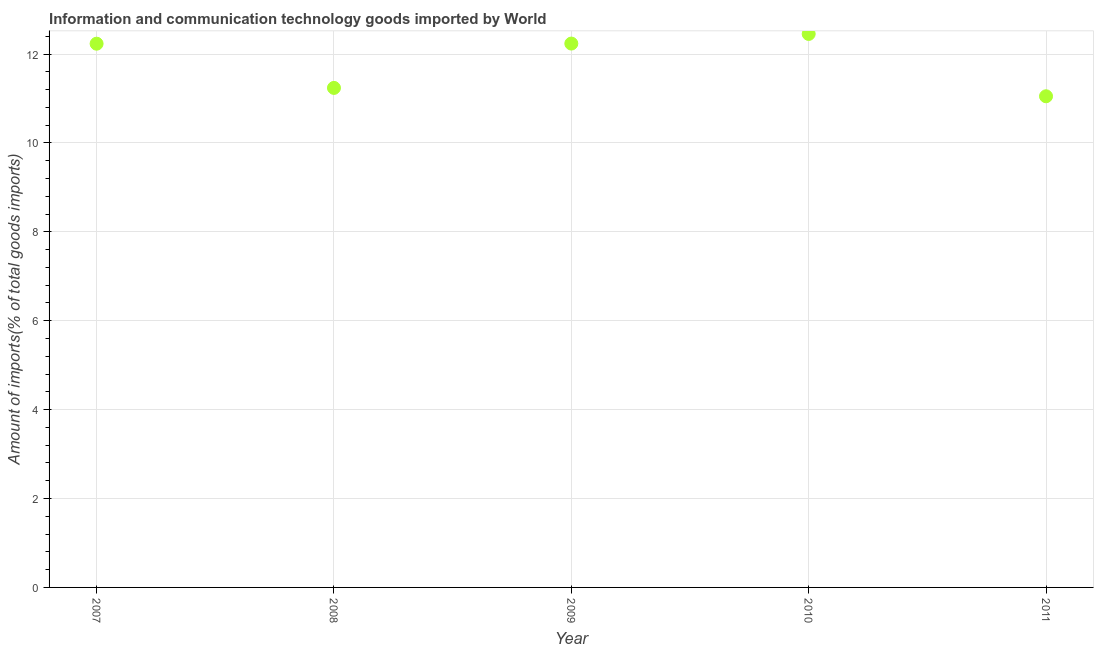What is the amount of ict goods imports in 2010?
Offer a very short reply. 12.45. Across all years, what is the maximum amount of ict goods imports?
Make the answer very short. 12.45. Across all years, what is the minimum amount of ict goods imports?
Ensure brevity in your answer.  11.05. In which year was the amount of ict goods imports maximum?
Your answer should be very brief. 2010. In which year was the amount of ict goods imports minimum?
Offer a terse response. 2011. What is the sum of the amount of ict goods imports?
Offer a terse response. 59.21. What is the difference between the amount of ict goods imports in 2008 and 2010?
Your response must be concise. -1.21. What is the average amount of ict goods imports per year?
Offer a terse response. 11.84. What is the median amount of ict goods imports?
Your response must be concise. 12.23. In how many years, is the amount of ict goods imports greater than 4.8 %?
Your answer should be compact. 5. Do a majority of the years between 2007 and 2008 (inclusive) have amount of ict goods imports greater than 5.2 %?
Your answer should be very brief. Yes. What is the ratio of the amount of ict goods imports in 2009 to that in 2010?
Your response must be concise. 0.98. Is the amount of ict goods imports in 2007 less than that in 2009?
Offer a terse response. Yes. What is the difference between the highest and the second highest amount of ict goods imports?
Offer a very short reply. 0.22. What is the difference between the highest and the lowest amount of ict goods imports?
Your response must be concise. 1.4. Does the amount of ict goods imports monotonically increase over the years?
Ensure brevity in your answer.  No. How many dotlines are there?
Ensure brevity in your answer.  1. How many years are there in the graph?
Keep it short and to the point. 5. What is the difference between two consecutive major ticks on the Y-axis?
Give a very brief answer. 2. Does the graph contain any zero values?
Your response must be concise. No. What is the title of the graph?
Provide a short and direct response. Information and communication technology goods imported by World. What is the label or title of the Y-axis?
Provide a succinct answer. Amount of imports(% of total goods imports). What is the Amount of imports(% of total goods imports) in 2007?
Your answer should be very brief. 12.23. What is the Amount of imports(% of total goods imports) in 2008?
Your answer should be compact. 11.24. What is the Amount of imports(% of total goods imports) in 2009?
Offer a terse response. 12.24. What is the Amount of imports(% of total goods imports) in 2010?
Ensure brevity in your answer.  12.45. What is the Amount of imports(% of total goods imports) in 2011?
Your answer should be compact. 11.05. What is the difference between the Amount of imports(% of total goods imports) in 2007 and 2008?
Your response must be concise. 0.99. What is the difference between the Amount of imports(% of total goods imports) in 2007 and 2009?
Provide a succinct answer. -0. What is the difference between the Amount of imports(% of total goods imports) in 2007 and 2010?
Offer a terse response. -0.22. What is the difference between the Amount of imports(% of total goods imports) in 2007 and 2011?
Ensure brevity in your answer.  1.18. What is the difference between the Amount of imports(% of total goods imports) in 2008 and 2009?
Your response must be concise. -1. What is the difference between the Amount of imports(% of total goods imports) in 2008 and 2010?
Offer a terse response. -1.21. What is the difference between the Amount of imports(% of total goods imports) in 2008 and 2011?
Provide a succinct answer. 0.19. What is the difference between the Amount of imports(% of total goods imports) in 2009 and 2010?
Your response must be concise. -0.22. What is the difference between the Amount of imports(% of total goods imports) in 2009 and 2011?
Offer a terse response. 1.19. What is the difference between the Amount of imports(% of total goods imports) in 2010 and 2011?
Your answer should be very brief. 1.4. What is the ratio of the Amount of imports(% of total goods imports) in 2007 to that in 2008?
Offer a terse response. 1.09. What is the ratio of the Amount of imports(% of total goods imports) in 2007 to that in 2009?
Ensure brevity in your answer.  1. What is the ratio of the Amount of imports(% of total goods imports) in 2007 to that in 2010?
Your answer should be very brief. 0.98. What is the ratio of the Amount of imports(% of total goods imports) in 2007 to that in 2011?
Offer a very short reply. 1.11. What is the ratio of the Amount of imports(% of total goods imports) in 2008 to that in 2009?
Provide a short and direct response. 0.92. What is the ratio of the Amount of imports(% of total goods imports) in 2008 to that in 2010?
Your response must be concise. 0.9. What is the ratio of the Amount of imports(% of total goods imports) in 2008 to that in 2011?
Provide a short and direct response. 1.02. What is the ratio of the Amount of imports(% of total goods imports) in 2009 to that in 2011?
Your answer should be very brief. 1.11. What is the ratio of the Amount of imports(% of total goods imports) in 2010 to that in 2011?
Keep it short and to the point. 1.13. 